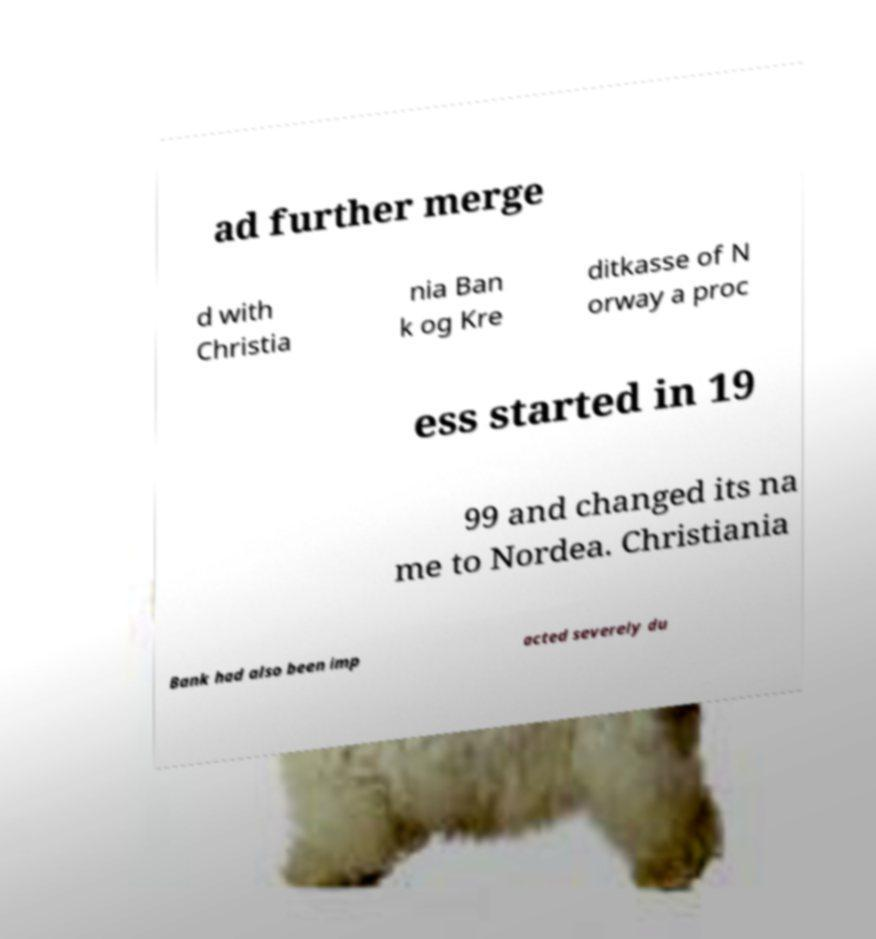For documentation purposes, I need the text within this image transcribed. Could you provide that? ad further merge d with Christia nia Ban k og Kre ditkasse of N orway a proc ess started in 19 99 and changed its na me to Nordea. Christiania Bank had also been imp acted severely du 